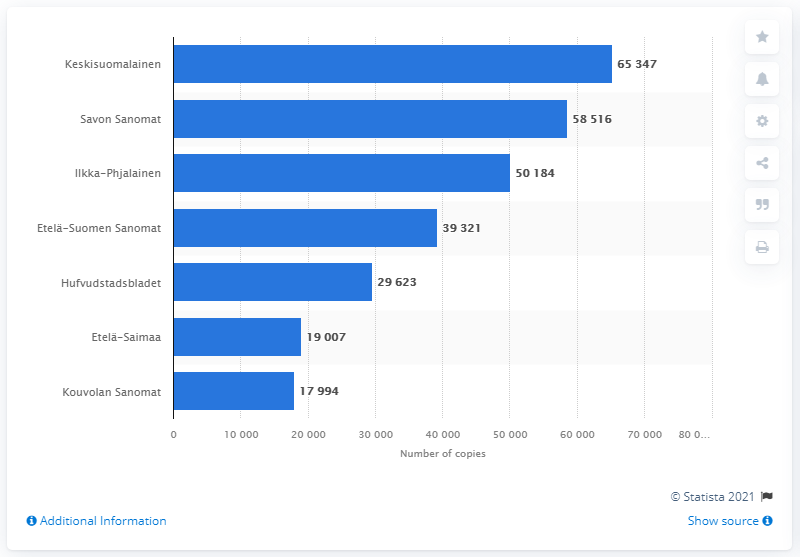Give some essential details in this illustration. Savon Sanomat was the second largest newspaper in Finland in 2020. In 2020, Keskisuomalainen had a total of 65,347 copies. The largest daily newspaper in Finland in 2020 was Keskisuomalainen. 